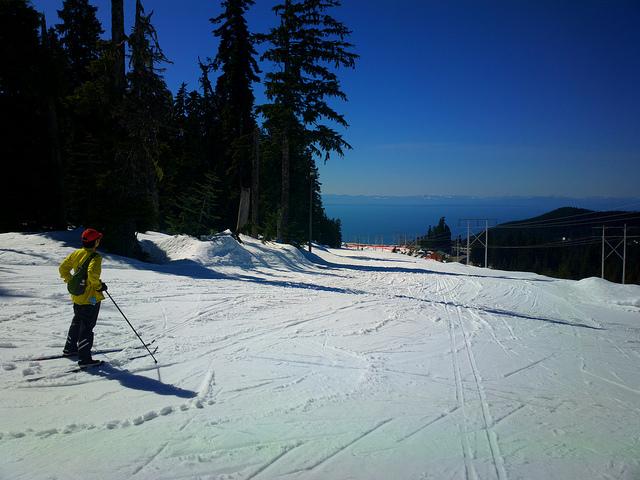Is this person skiing or snowboarding?
Answer briefly. Skiing. What color is the jacket of the person in the forefront?
Give a very brief answer. Yellow. Is the skier the first one to take this trail?
Be succinct. No. What color is the person's hat?
Answer briefly. Red. 